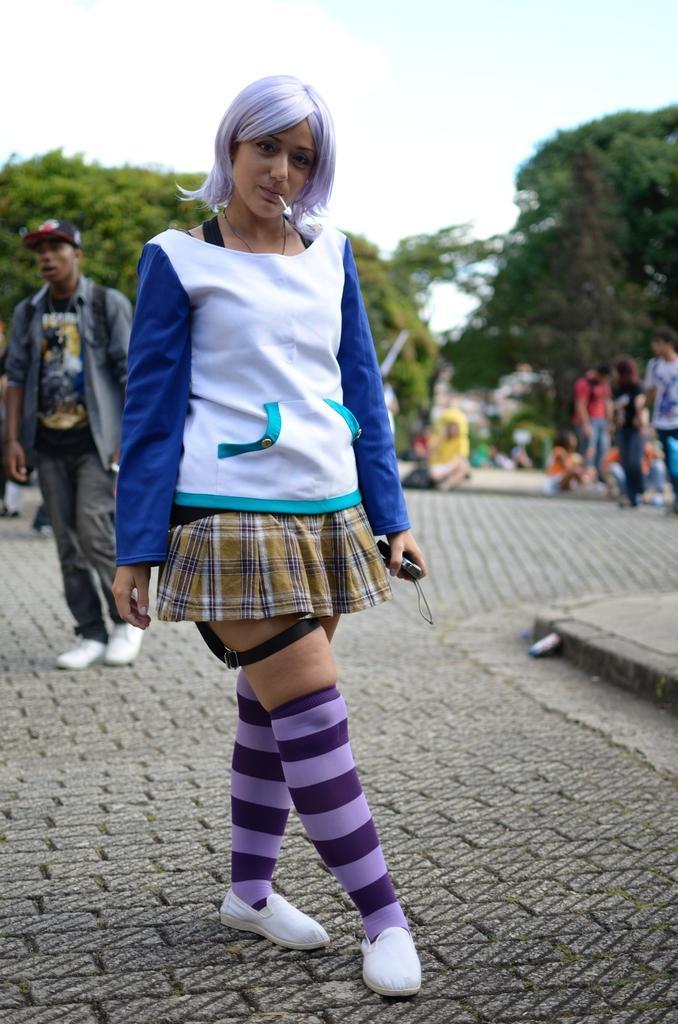In one or two sentences, can you explain what this image depicts? In this picture there is a woman who is holding camera. Backside of her there is a man who is wearing cap, shirt, t-shirt, bag, jeans and sneakers. On the right background we can see the group of persons. In the background we can see building and trees. At the top we can see sky and clouds. 